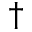Convert formula to latex. <formula><loc_0><loc_0><loc_500><loc_500>^ { \dagger }</formula> 